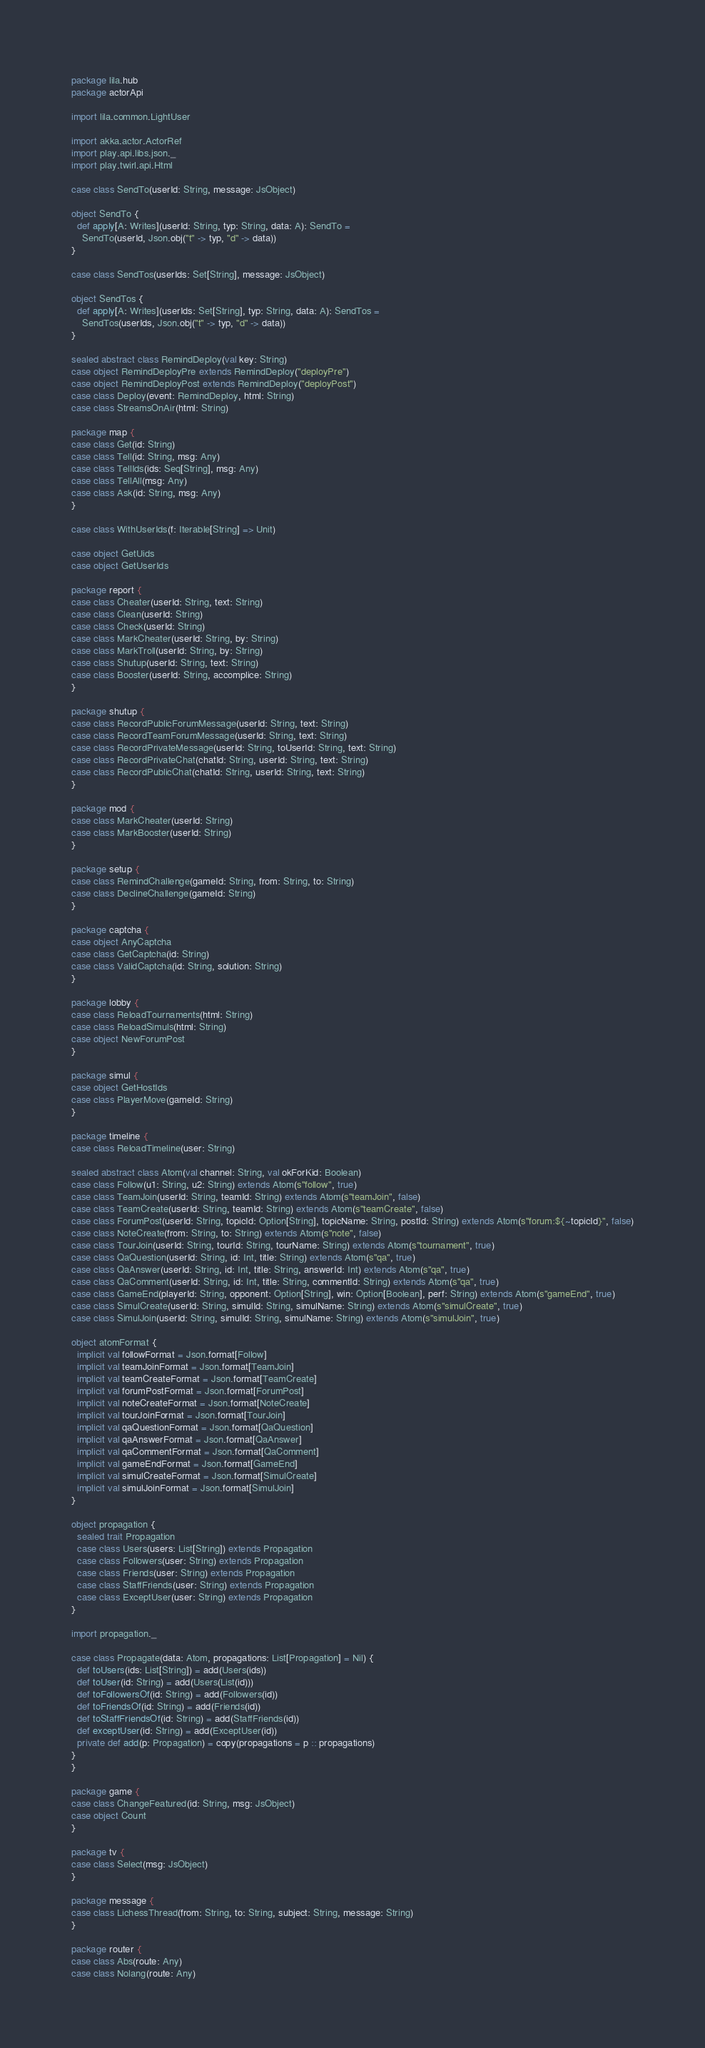Convert code to text. <code><loc_0><loc_0><loc_500><loc_500><_Scala_>package lila.hub
package actorApi

import lila.common.LightUser

import akka.actor.ActorRef
import play.api.libs.json._
import play.twirl.api.Html

case class SendTo(userId: String, message: JsObject)

object SendTo {
  def apply[A: Writes](userId: String, typ: String, data: A): SendTo =
    SendTo(userId, Json.obj("t" -> typ, "d" -> data))
}

case class SendTos(userIds: Set[String], message: JsObject)

object SendTos {
  def apply[A: Writes](userIds: Set[String], typ: String, data: A): SendTos =
    SendTos(userIds, Json.obj("t" -> typ, "d" -> data))
}

sealed abstract class RemindDeploy(val key: String)
case object RemindDeployPre extends RemindDeploy("deployPre")
case object RemindDeployPost extends RemindDeploy("deployPost")
case class Deploy(event: RemindDeploy, html: String)
case class StreamsOnAir(html: String)

package map {
case class Get(id: String)
case class Tell(id: String, msg: Any)
case class TellIds(ids: Seq[String], msg: Any)
case class TellAll(msg: Any)
case class Ask(id: String, msg: Any)
}

case class WithUserIds(f: Iterable[String] => Unit)

case object GetUids
case object GetUserIds

package report {
case class Cheater(userId: String, text: String)
case class Clean(userId: String)
case class Check(userId: String)
case class MarkCheater(userId: String, by: String)
case class MarkTroll(userId: String, by: String)
case class Shutup(userId: String, text: String)
case class Booster(userId: String, accomplice: String)
}

package shutup {
case class RecordPublicForumMessage(userId: String, text: String)
case class RecordTeamForumMessage(userId: String, text: String)
case class RecordPrivateMessage(userId: String, toUserId: String, text: String)
case class RecordPrivateChat(chatId: String, userId: String, text: String)
case class RecordPublicChat(chatId: String, userId: String, text: String)
}

package mod {
case class MarkCheater(userId: String)
case class MarkBooster(userId: String)
}

package setup {
case class RemindChallenge(gameId: String, from: String, to: String)
case class DeclineChallenge(gameId: String)
}

package captcha {
case object AnyCaptcha
case class GetCaptcha(id: String)
case class ValidCaptcha(id: String, solution: String)
}

package lobby {
case class ReloadTournaments(html: String)
case class ReloadSimuls(html: String)
case object NewForumPost
}

package simul {
case object GetHostIds
case class PlayerMove(gameId: String)
}

package timeline {
case class ReloadTimeline(user: String)

sealed abstract class Atom(val channel: String, val okForKid: Boolean)
case class Follow(u1: String, u2: String) extends Atom(s"follow", true)
case class TeamJoin(userId: String, teamId: String) extends Atom(s"teamJoin", false)
case class TeamCreate(userId: String, teamId: String) extends Atom(s"teamCreate", false)
case class ForumPost(userId: String, topicId: Option[String], topicName: String, postId: String) extends Atom(s"forum:${~topicId}", false)
case class NoteCreate(from: String, to: String) extends Atom(s"note", false)
case class TourJoin(userId: String, tourId: String, tourName: String) extends Atom(s"tournament", true)
case class QaQuestion(userId: String, id: Int, title: String) extends Atom(s"qa", true)
case class QaAnswer(userId: String, id: Int, title: String, answerId: Int) extends Atom(s"qa", true)
case class QaComment(userId: String, id: Int, title: String, commentId: String) extends Atom(s"qa", true)
case class GameEnd(playerId: String, opponent: Option[String], win: Option[Boolean], perf: String) extends Atom(s"gameEnd", true)
case class SimulCreate(userId: String, simulId: String, simulName: String) extends Atom(s"simulCreate", true)
case class SimulJoin(userId: String, simulId: String, simulName: String) extends Atom(s"simulJoin", true)

object atomFormat {
  implicit val followFormat = Json.format[Follow]
  implicit val teamJoinFormat = Json.format[TeamJoin]
  implicit val teamCreateFormat = Json.format[TeamCreate]
  implicit val forumPostFormat = Json.format[ForumPost]
  implicit val noteCreateFormat = Json.format[NoteCreate]
  implicit val tourJoinFormat = Json.format[TourJoin]
  implicit val qaQuestionFormat = Json.format[QaQuestion]
  implicit val qaAnswerFormat = Json.format[QaAnswer]
  implicit val qaCommentFormat = Json.format[QaComment]
  implicit val gameEndFormat = Json.format[GameEnd]
  implicit val simulCreateFormat = Json.format[SimulCreate]
  implicit val simulJoinFormat = Json.format[SimulJoin]
}

object propagation {
  sealed trait Propagation
  case class Users(users: List[String]) extends Propagation
  case class Followers(user: String) extends Propagation
  case class Friends(user: String) extends Propagation
  case class StaffFriends(user: String) extends Propagation
  case class ExceptUser(user: String) extends Propagation
}

import propagation._

case class Propagate(data: Atom, propagations: List[Propagation] = Nil) {
  def toUsers(ids: List[String]) = add(Users(ids))
  def toUser(id: String) = add(Users(List(id)))
  def toFollowersOf(id: String) = add(Followers(id))
  def toFriendsOf(id: String) = add(Friends(id))
  def toStaffFriendsOf(id: String) = add(StaffFriends(id))
  def exceptUser(id: String) = add(ExceptUser(id))
  private def add(p: Propagation) = copy(propagations = p :: propagations)
}
}

package game {
case class ChangeFeatured(id: String, msg: JsObject)
case object Count
}

package tv {
case class Select(msg: JsObject)
}

package message {
case class LichessThread(from: String, to: String, subject: String, message: String)
}

package router {
case class Abs(route: Any)
case class Nolang(route: Any)</code> 